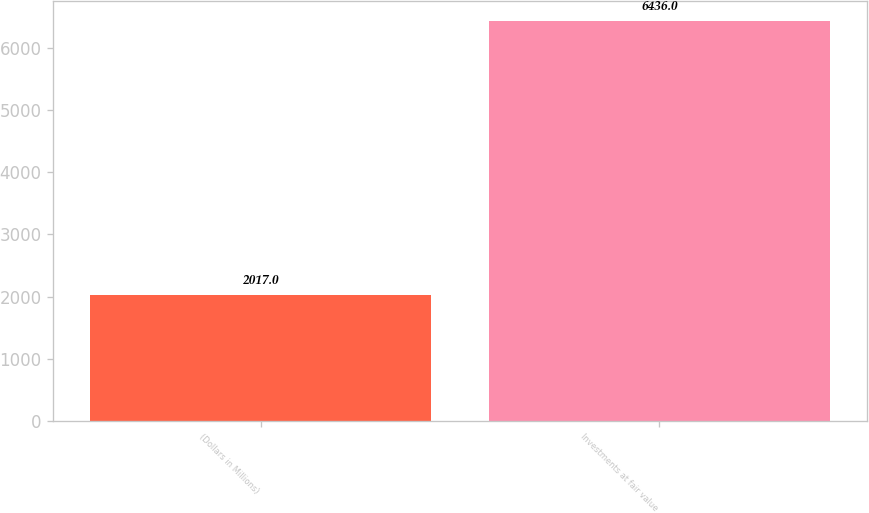Convert chart to OTSL. <chart><loc_0><loc_0><loc_500><loc_500><bar_chart><fcel>(Dollars in Millions)<fcel>Investments at fair value<nl><fcel>2017<fcel>6436<nl></chart> 